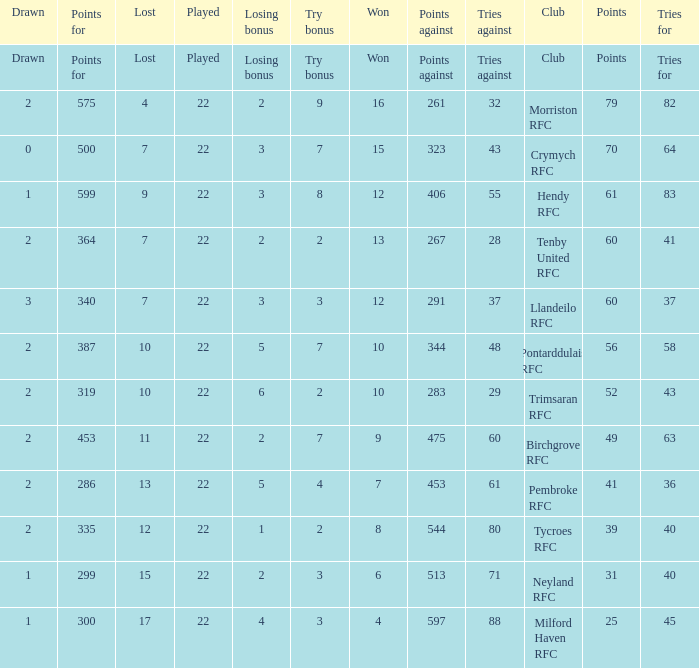What's the points with tries for being 64 70.0. 